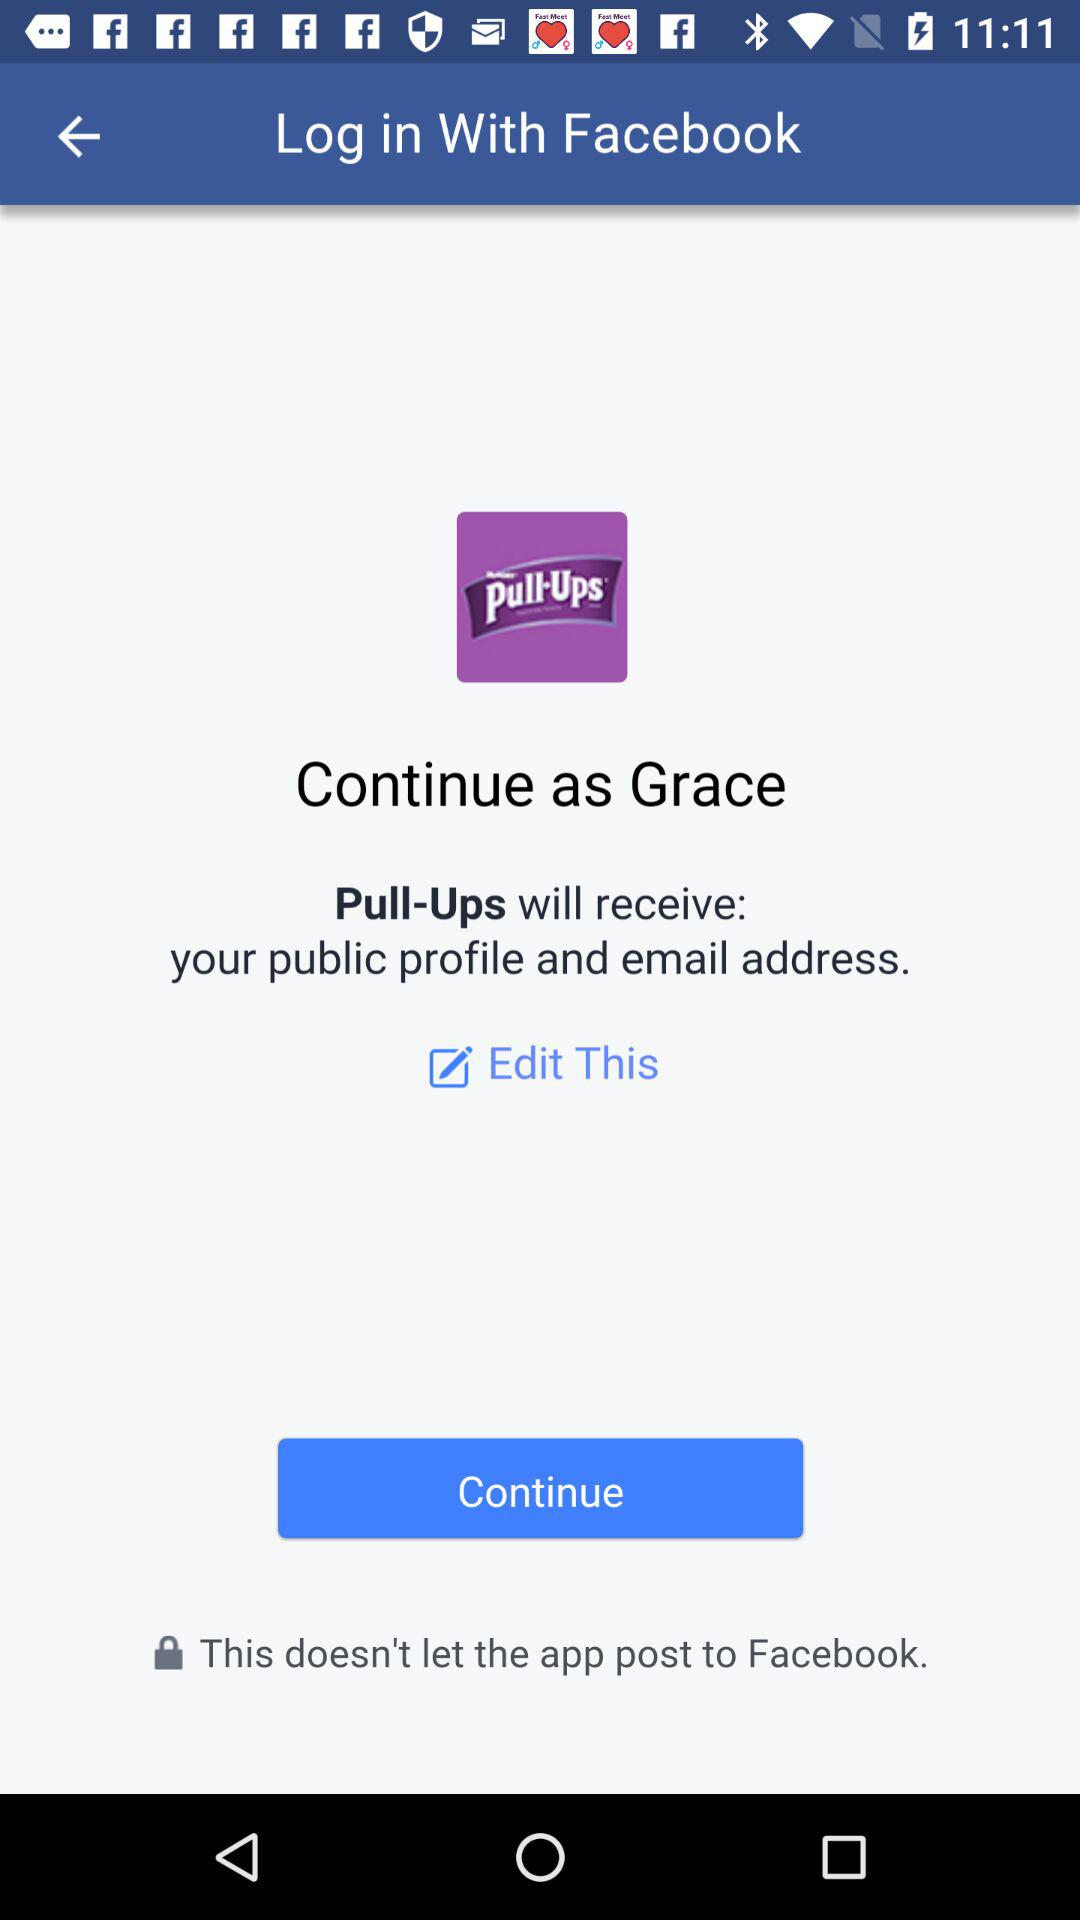What application will receive the public profile and email address? The application that will receive the public profile and email address is "Pull-Ups". 